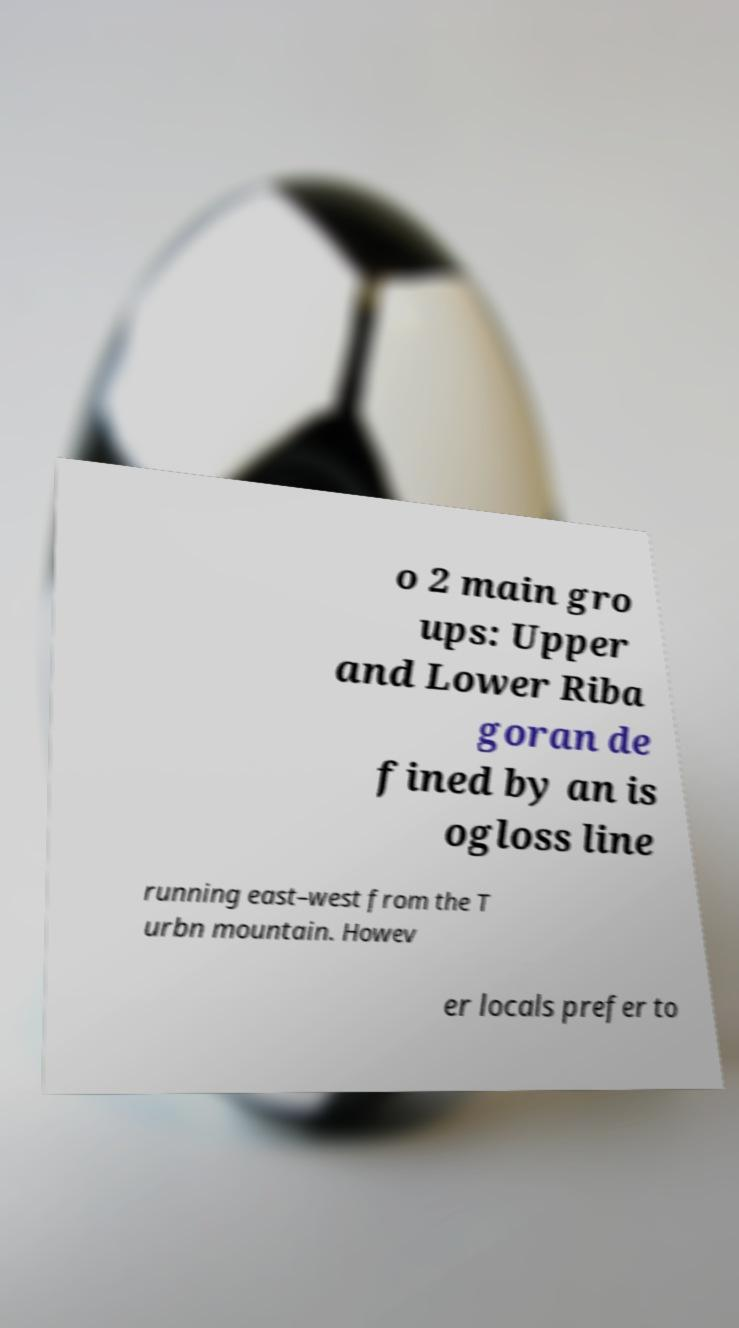Please identify and transcribe the text found in this image. o 2 main gro ups: Upper and Lower Riba goran de fined by an is ogloss line running east–west from the T urbn mountain. Howev er locals prefer to 